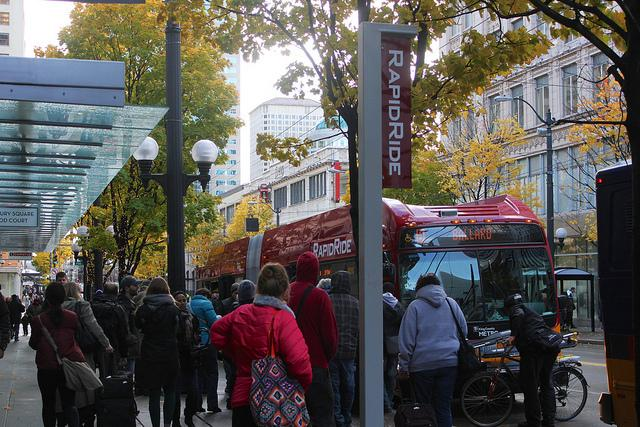What area is shown here?

Choices:
A) bus stop
B) cake walk
C) taxi stand
D) bike pull bus stop 